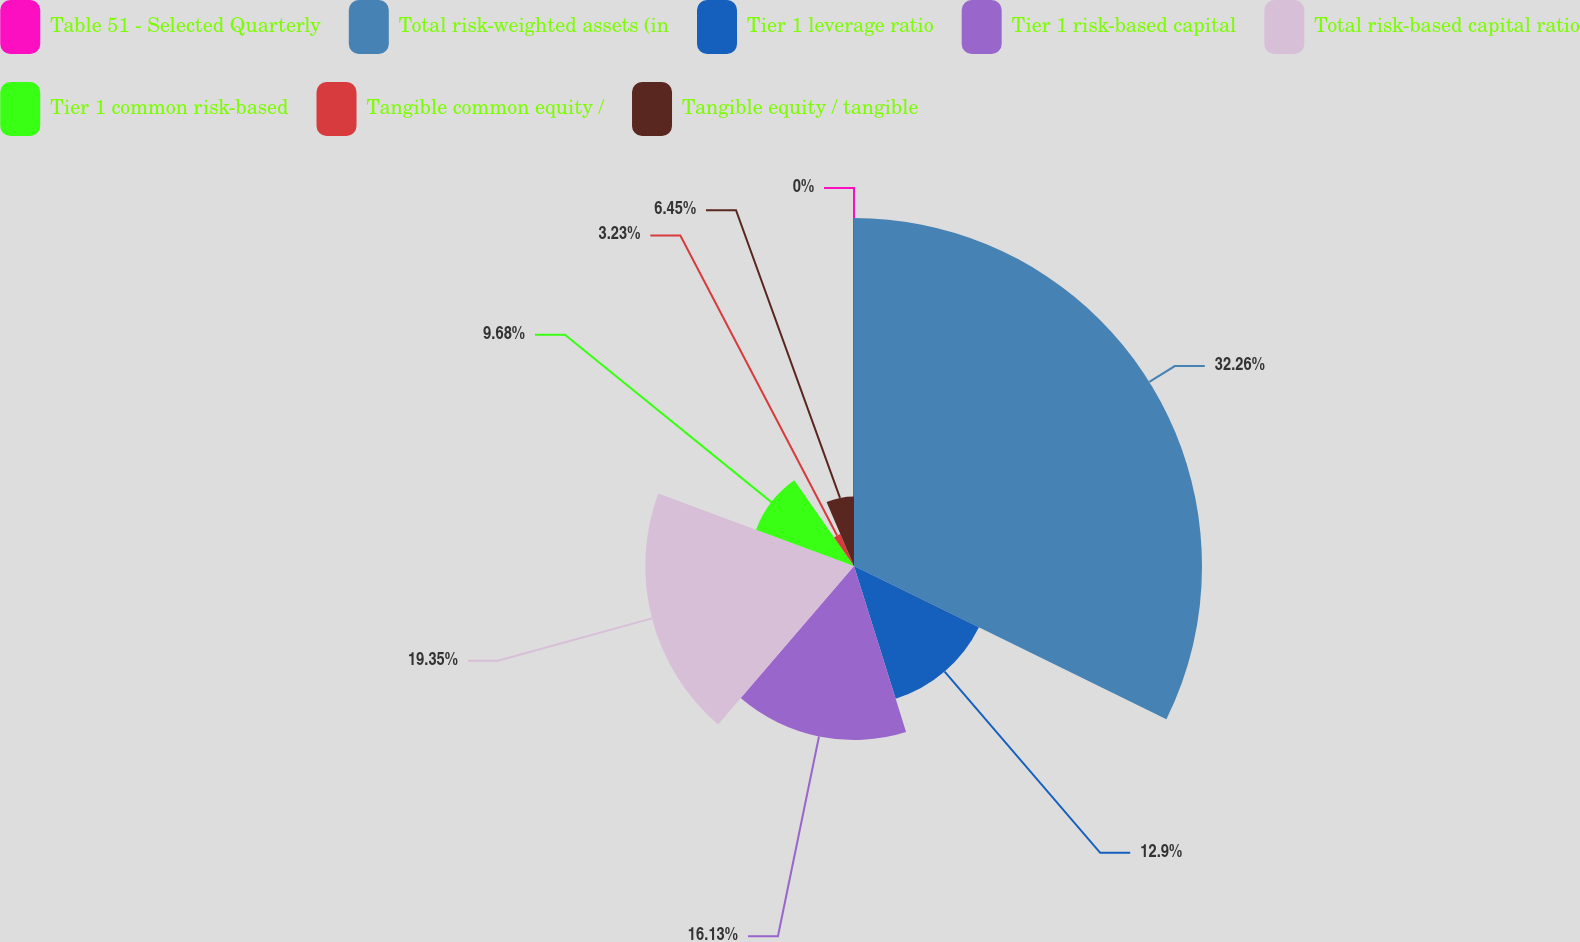Convert chart. <chart><loc_0><loc_0><loc_500><loc_500><pie_chart><fcel>Table 51 - Selected Quarterly<fcel>Total risk-weighted assets (in<fcel>Tier 1 leverage ratio<fcel>Tier 1 risk-based capital<fcel>Total risk-based capital ratio<fcel>Tier 1 common risk-based<fcel>Tangible common equity /<fcel>Tangible equity / tangible<nl><fcel>0.0%<fcel>32.26%<fcel>12.9%<fcel>16.13%<fcel>19.35%<fcel>9.68%<fcel>3.23%<fcel>6.45%<nl></chart> 